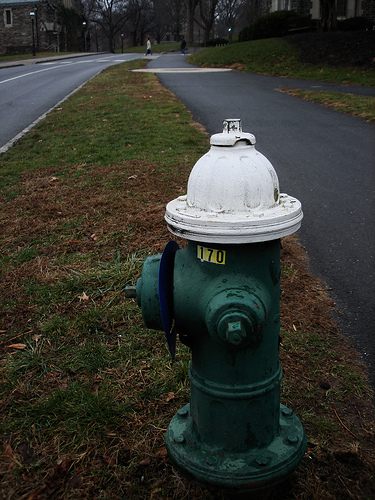Please provide a short description for this region: [0.12, 0.0, 0.32, 0.11]. This section of the image, cover a country styled home viewed from across the street, gives a picturesque and inviting ambiance to the setting, enhancing the street’s residential character. 